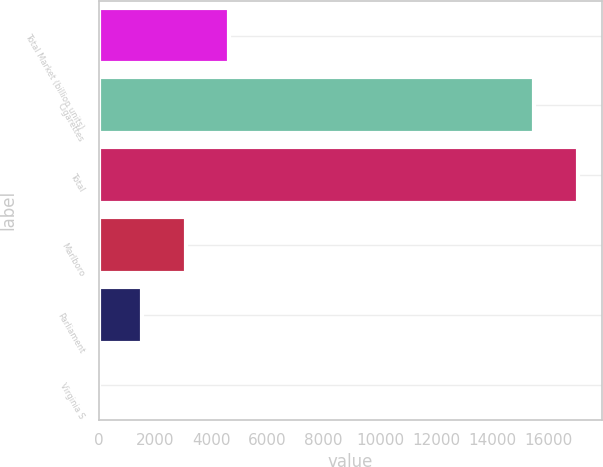<chart> <loc_0><loc_0><loc_500><loc_500><bar_chart><fcel>Total Market (billion units)<fcel>Cigarettes<fcel>Total<fcel>Marlboro<fcel>Parliament<fcel>Virginia S<nl><fcel>4649.1<fcel>15490<fcel>17038.7<fcel>3100.4<fcel>1551.7<fcel>3<nl></chart> 